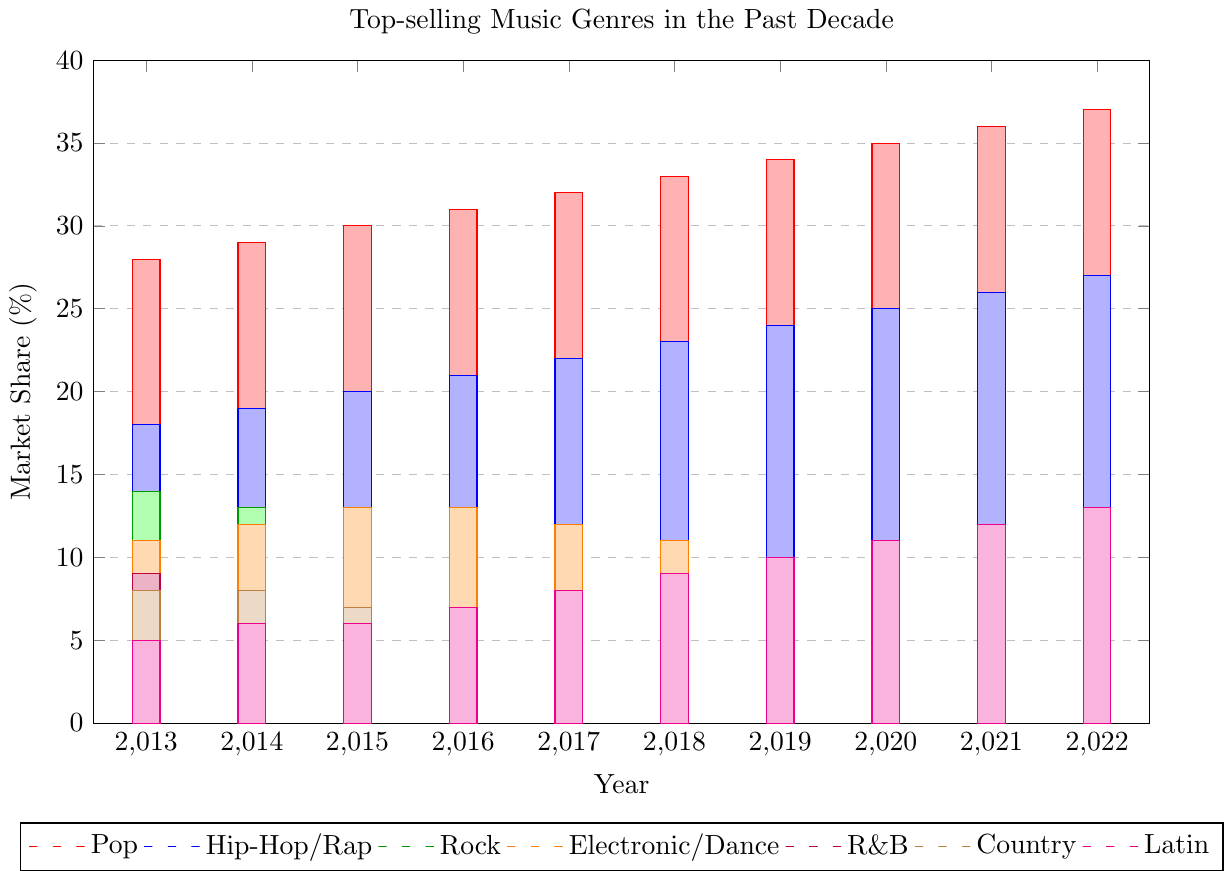What genre has experienced the most significant growth in market share from 2013 to 2022? Pop genre has increased from 28% in 2013 to 37% in 2022. This is the most significant increase among all genres in the given period based on the plotted data.
Answer: Pop Which two genres had the same market share in 2016 and how much was it? In 2016, Electronic/Dance and Rock had the same market share, each at 13%. You can see the bars representing these genres at the same height for this year.
Answer: Electronic/Dance and Rock, 13% Compare the market share of Latin music in 2013 and 2022. Which year had a higher share and by how much? In 2013, Latin music had a market share of 5%, and in 2022, it had 13%. The market share in 2022 is 8% higher than in 2013.
Answer: 2022, 8% Which genre had a decreasing trend in market share every year from 2013 to 2022? Rock genre had a continuously decreasing trend from 14% in 2013 to 5% in 2022, as seen from the bars getting shorter each year in the graph.
Answer: Rock Calculate the average market share of Hip-Hop/Rap over the decade. To find the average, sum the market shares from 2013 to 2022 and divide by the number of years. (18+19+20+21+22+23+24+25+26+27) / 10 = 22.5%
Answer: 22.5% Which genre held a constant market share in two consecutive years, and in which years did this occur? The Country genre had a constant market share of 8% in both 2013 and 2014, as indicated by the bars at the same height for these years.
Answer: Country, 2013 and 2014 Between Pop and R&B genres, which one had a larger market share in 2022, and by how much? In 2022, Pop had 37%, while R&B had 4%. Pop's market share was 33% higher. You can notice Pop's dominant presence with the highest bar.
Answer: Pop, 33% Compare the market share of the Electronic/Dance genre in 2013 and 2020. How does it change? The market share for Electronic/Dance decreased from 11% in 2013 to 9% in 2020. This shows a reduction of 2%.
Answer: Decreased by 2% What is the sum of the market share percentages for Hip-Hop/Rap and Latin genres in 2017? Hip-Hop/Rap had a market share of 22% while Latin had 8% in 2017. Summing these gives 22% + 8% = 30%.
Answer: 30% 